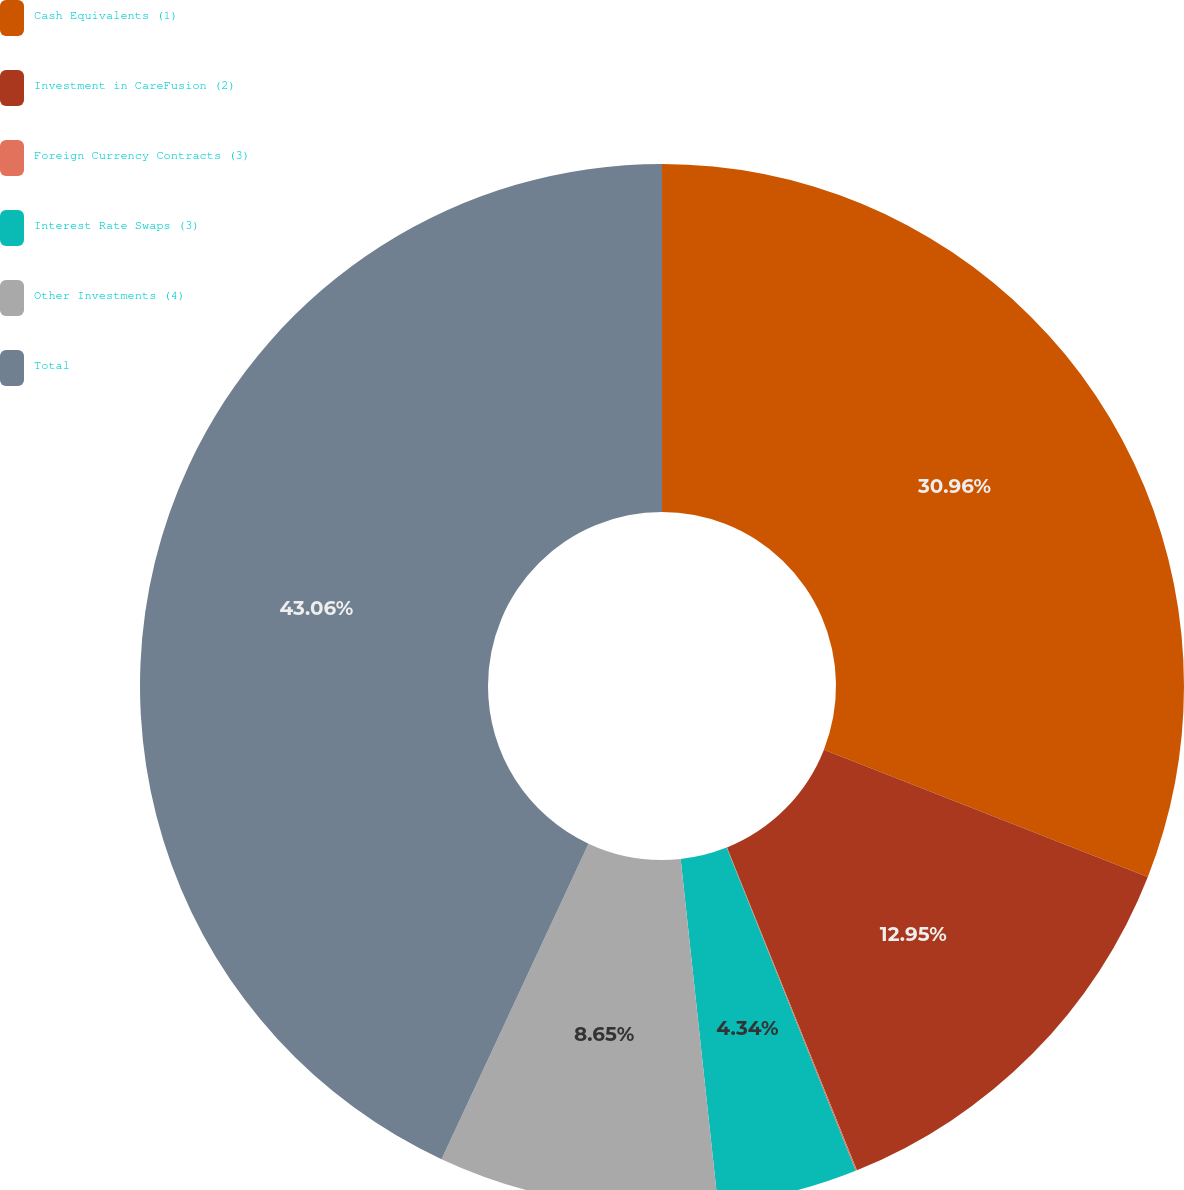<chart> <loc_0><loc_0><loc_500><loc_500><pie_chart><fcel>Cash Equivalents (1)<fcel>Investment in CareFusion (2)<fcel>Foreign Currency Contracts (3)<fcel>Interest Rate Swaps (3)<fcel>Other Investments (4)<fcel>Total<nl><fcel>30.96%<fcel>12.95%<fcel>0.04%<fcel>4.34%<fcel>8.65%<fcel>43.06%<nl></chart> 